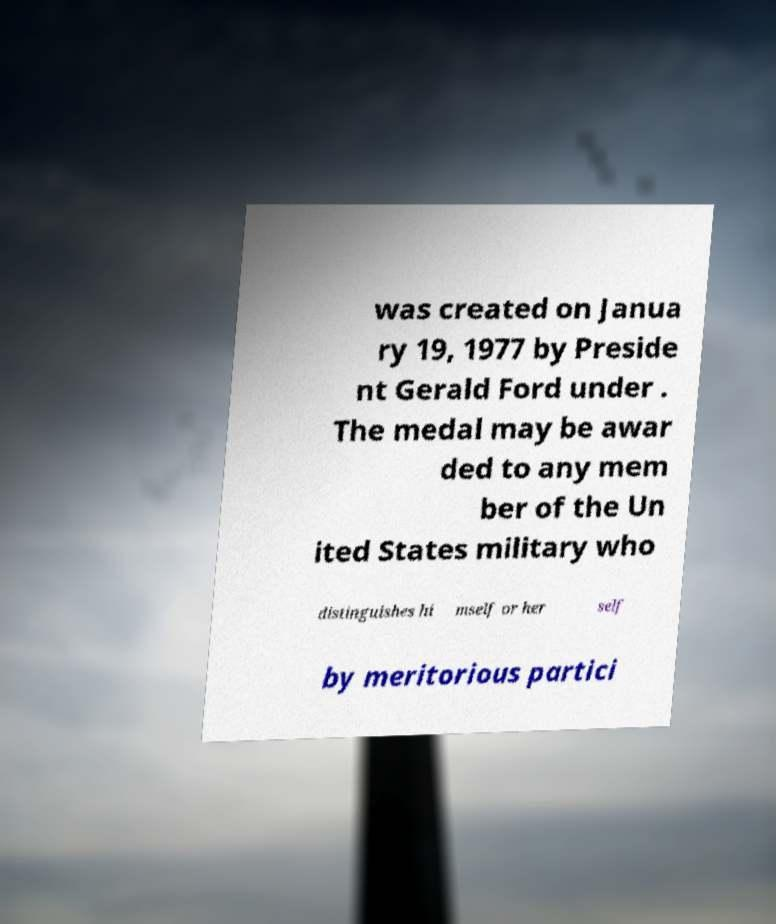Could you assist in decoding the text presented in this image and type it out clearly? was created on Janua ry 19, 1977 by Preside nt Gerald Ford under . The medal may be awar ded to any mem ber of the Un ited States military who distinguishes hi mself or her self by meritorious partici 